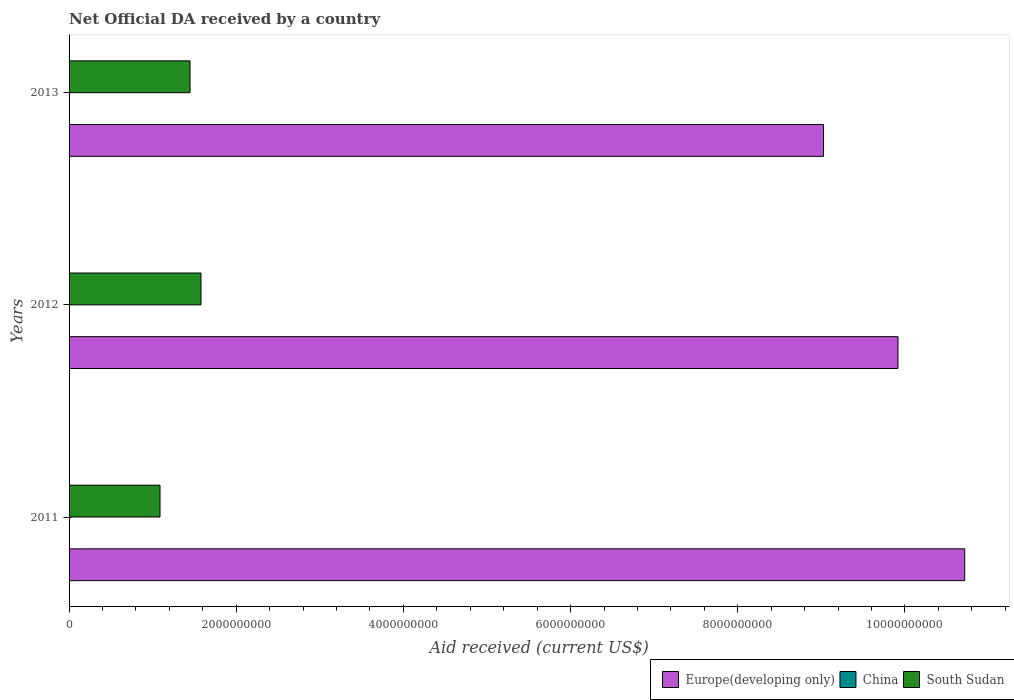How many different coloured bars are there?
Keep it short and to the point. 2. How many groups of bars are there?
Your answer should be very brief. 3. How many bars are there on the 3rd tick from the bottom?
Your answer should be compact. 2. What is the net official development assistance aid received in South Sudan in 2011?
Provide a succinct answer. 1.09e+09. Across all years, what is the maximum net official development assistance aid received in Europe(developing only)?
Offer a very short reply. 1.07e+1. What is the total net official development assistance aid received in Europe(developing only) in the graph?
Your answer should be compact. 2.97e+1. What is the difference between the net official development assistance aid received in Europe(developing only) in 2011 and that in 2012?
Your response must be concise. 7.98e+08. What is the difference between the net official development assistance aid received in China in 2011 and the net official development assistance aid received in Europe(developing only) in 2012?
Keep it short and to the point. -9.92e+09. What is the average net official development assistance aid received in China per year?
Offer a terse response. 0. In the year 2011, what is the difference between the net official development assistance aid received in South Sudan and net official development assistance aid received in Europe(developing only)?
Your answer should be very brief. -9.63e+09. What is the ratio of the net official development assistance aid received in South Sudan in 2012 to that in 2013?
Give a very brief answer. 1.09. Is the net official development assistance aid received in South Sudan in 2012 less than that in 2013?
Your response must be concise. No. Is the difference between the net official development assistance aid received in South Sudan in 2012 and 2013 greater than the difference between the net official development assistance aid received in Europe(developing only) in 2012 and 2013?
Your answer should be compact. No. What is the difference between the highest and the second highest net official development assistance aid received in South Sudan?
Make the answer very short. 1.31e+08. What is the difference between the highest and the lowest net official development assistance aid received in Europe(developing only)?
Make the answer very short. 1.69e+09. In how many years, is the net official development assistance aid received in China greater than the average net official development assistance aid received in China taken over all years?
Offer a terse response. 0. Is it the case that in every year, the sum of the net official development assistance aid received in Europe(developing only) and net official development assistance aid received in South Sudan is greater than the net official development assistance aid received in China?
Your answer should be compact. Yes. Are all the bars in the graph horizontal?
Make the answer very short. Yes. How many years are there in the graph?
Make the answer very short. 3. Are the values on the major ticks of X-axis written in scientific E-notation?
Make the answer very short. No. Does the graph contain any zero values?
Give a very brief answer. Yes. Does the graph contain grids?
Give a very brief answer. No. How many legend labels are there?
Give a very brief answer. 3. What is the title of the graph?
Offer a terse response. Net Official DA received by a country. What is the label or title of the X-axis?
Offer a terse response. Aid received (current US$). What is the Aid received (current US$) of Europe(developing only) in 2011?
Ensure brevity in your answer.  1.07e+1. What is the Aid received (current US$) in China in 2011?
Your response must be concise. 0. What is the Aid received (current US$) in South Sudan in 2011?
Provide a short and direct response. 1.09e+09. What is the Aid received (current US$) of Europe(developing only) in 2012?
Your response must be concise. 9.92e+09. What is the Aid received (current US$) in South Sudan in 2012?
Your answer should be very brief. 1.58e+09. What is the Aid received (current US$) in Europe(developing only) in 2013?
Your answer should be compact. 9.03e+09. What is the Aid received (current US$) in China in 2013?
Give a very brief answer. 0. What is the Aid received (current US$) in South Sudan in 2013?
Provide a short and direct response. 1.45e+09. Across all years, what is the maximum Aid received (current US$) in Europe(developing only)?
Provide a short and direct response. 1.07e+1. Across all years, what is the maximum Aid received (current US$) of South Sudan?
Ensure brevity in your answer.  1.58e+09. Across all years, what is the minimum Aid received (current US$) of Europe(developing only)?
Make the answer very short. 9.03e+09. Across all years, what is the minimum Aid received (current US$) of South Sudan?
Make the answer very short. 1.09e+09. What is the total Aid received (current US$) in Europe(developing only) in the graph?
Give a very brief answer. 2.97e+1. What is the total Aid received (current US$) in China in the graph?
Give a very brief answer. 0. What is the total Aid received (current US$) in South Sudan in the graph?
Your answer should be very brief. 4.11e+09. What is the difference between the Aid received (current US$) in Europe(developing only) in 2011 and that in 2012?
Offer a terse response. 7.98e+08. What is the difference between the Aid received (current US$) in South Sudan in 2011 and that in 2012?
Your answer should be very brief. -4.90e+08. What is the difference between the Aid received (current US$) in Europe(developing only) in 2011 and that in 2013?
Your response must be concise. 1.69e+09. What is the difference between the Aid received (current US$) of South Sudan in 2011 and that in 2013?
Make the answer very short. -3.59e+08. What is the difference between the Aid received (current US$) in Europe(developing only) in 2012 and that in 2013?
Your response must be concise. 8.91e+08. What is the difference between the Aid received (current US$) in South Sudan in 2012 and that in 2013?
Make the answer very short. 1.31e+08. What is the difference between the Aid received (current US$) of Europe(developing only) in 2011 and the Aid received (current US$) of South Sudan in 2012?
Make the answer very short. 9.14e+09. What is the difference between the Aid received (current US$) of Europe(developing only) in 2011 and the Aid received (current US$) of South Sudan in 2013?
Your answer should be compact. 9.27e+09. What is the difference between the Aid received (current US$) in Europe(developing only) in 2012 and the Aid received (current US$) in South Sudan in 2013?
Offer a terse response. 8.47e+09. What is the average Aid received (current US$) in Europe(developing only) per year?
Provide a succinct answer. 9.89e+09. What is the average Aid received (current US$) in China per year?
Offer a very short reply. 0. What is the average Aid received (current US$) in South Sudan per year?
Ensure brevity in your answer.  1.37e+09. In the year 2011, what is the difference between the Aid received (current US$) in Europe(developing only) and Aid received (current US$) in South Sudan?
Your answer should be very brief. 9.63e+09. In the year 2012, what is the difference between the Aid received (current US$) in Europe(developing only) and Aid received (current US$) in South Sudan?
Provide a short and direct response. 8.34e+09. In the year 2013, what is the difference between the Aid received (current US$) of Europe(developing only) and Aid received (current US$) of South Sudan?
Offer a very short reply. 7.58e+09. What is the ratio of the Aid received (current US$) of Europe(developing only) in 2011 to that in 2012?
Your answer should be very brief. 1.08. What is the ratio of the Aid received (current US$) in South Sudan in 2011 to that in 2012?
Your answer should be compact. 0.69. What is the ratio of the Aid received (current US$) in Europe(developing only) in 2011 to that in 2013?
Provide a short and direct response. 1.19. What is the ratio of the Aid received (current US$) of South Sudan in 2011 to that in 2013?
Offer a very short reply. 0.75. What is the ratio of the Aid received (current US$) in Europe(developing only) in 2012 to that in 2013?
Keep it short and to the point. 1.1. What is the ratio of the Aid received (current US$) of South Sudan in 2012 to that in 2013?
Provide a short and direct response. 1.09. What is the difference between the highest and the second highest Aid received (current US$) of Europe(developing only)?
Give a very brief answer. 7.98e+08. What is the difference between the highest and the second highest Aid received (current US$) in South Sudan?
Provide a succinct answer. 1.31e+08. What is the difference between the highest and the lowest Aid received (current US$) of Europe(developing only)?
Make the answer very short. 1.69e+09. What is the difference between the highest and the lowest Aid received (current US$) of South Sudan?
Ensure brevity in your answer.  4.90e+08. 